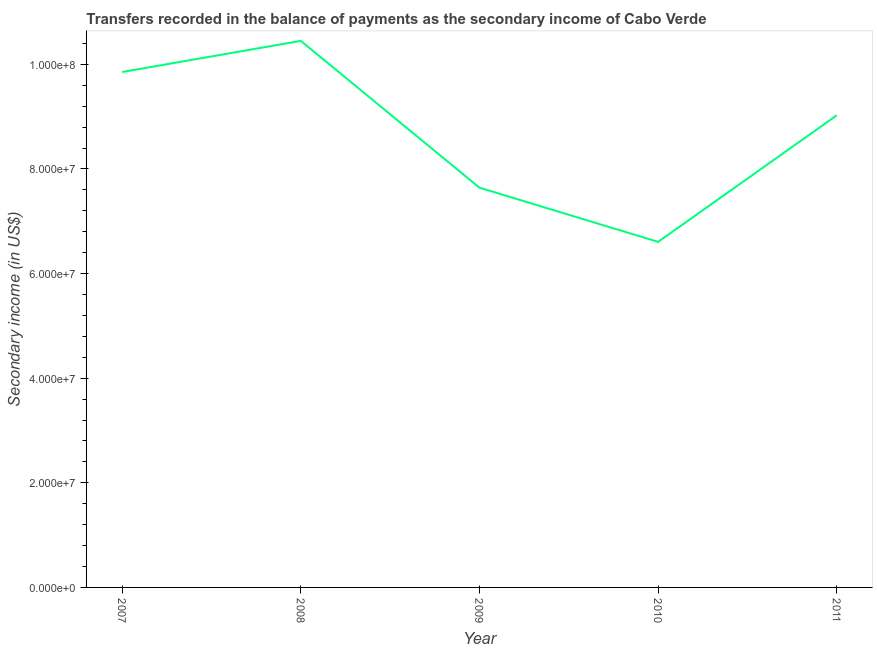What is the amount of secondary income in 2009?
Your answer should be very brief. 7.64e+07. Across all years, what is the maximum amount of secondary income?
Offer a very short reply. 1.04e+08. Across all years, what is the minimum amount of secondary income?
Your answer should be very brief. 6.61e+07. In which year was the amount of secondary income maximum?
Keep it short and to the point. 2008. What is the sum of the amount of secondary income?
Keep it short and to the point. 4.36e+08. What is the difference between the amount of secondary income in 2009 and 2010?
Offer a terse response. 1.04e+07. What is the average amount of secondary income per year?
Your answer should be very brief. 8.72e+07. What is the median amount of secondary income?
Provide a short and direct response. 9.03e+07. What is the ratio of the amount of secondary income in 2007 to that in 2008?
Ensure brevity in your answer.  0.94. Is the amount of secondary income in 2007 less than that in 2009?
Provide a short and direct response. No. Is the difference between the amount of secondary income in 2008 and 2010 greater than the difference between any two years?
Your answer should be very brief. Yes. What is the difference between the highest and the second highest amount of secondary income?
Make the answer very short. 5.95e+06. Is the sum of the amount of secondary income in 2007 and 2008 greater than the maximum amount of secondary income across all years?
Offer a terse response. Yes. What is the difference between the highest and the lowest amount of secondary income?
Your answer should be compact. 3.84e+07. Does the amount of secondary income monotonically increase over the years?
Your response must be concise. No. How many years are there in the graph?
Offer a terse response. 5. What is the title of the graph?
Offer a terse response. Transfers recorded in the balance of payments as the secondary income of Cabo Verde. What is the label or title of the X-axis?
Make the answer very short. Year. What is the label or title of the Y-axis?
Provide a succinct answer. Secondary income (in US$). What is the Secondary income (in US$) of 2007?
Offer a terse response. 9.85e+07. What is the Secondary income (in US$) of 2008?
Provide a succinct answer. 1.04e+08. What is the Secondary income (in US$) in 2009?
Provide a short and direct response. 7.64e+07. What is the Secondary income (in US$) of 2010?
Your answer should be compact. 6.61e+07. What is the Secondary income (in US$) in 2011?
Your answer should be very brief. 9.03e+07. What is the difference between the Secondary income (in US$) in 2007 and 2008?
Your response must be concise. -5.95e+06. What is the difference between the Secondary income (in US$) in 2007 and 2009?
Provide a short and direct response. 2.21e+07. What is the difference between the Secondary income (in US$) in 2007 and 2010?
Ensure brevity in your answer.  3.25e+07. What is the difference between the Secondary income (in US$) in 2007 and 2011?
Offer a very short reply. 8.28e+06. What is the difference between the Secondary income (in US$) in 2008 and 2009?
Your answer should be compact. 2.81e+07. What is the difference between the Secondary income (in US$) in 2008 and 2010?
Make the answer very short. 3.84e+07. What is the difference between the Secondary income (in US$) in 2008 and 2011?
Your answer should be compact. 1.42e+07. What is the difference between the Secondary income (in US$) in 2009 and 2010?
Give a very brief answer. 1.04e+07. What is the difference between the Secondary income (in US$) in 2009 and 2011?
Keep it short and to the point. -1.38e+07. What is the difference between the Secondary income (in US$) in 2010 and 2011?
Provide a short and direct response. -2.42e+07. What is the ratio of the Secondary income (in US$) in 2007 to that in 2008?
Offer a terse response. 0.94. What is the ratio of the Secondary income (in US$) in 2007 to that in 2009?
Your answer should be compact. 1.29. What is the ratio of the Secondary income (in US$) in 2007 to that in 2010?
Your answer should be compact. 1.49. What is the ratio of the Secondary income (in US$) in 2007 to that in 2011?
Keep it short and to the point. 1.09. What is the ratio of the Secondary income (in US$) in 2008 to that in 2009?
Ensure brevity in your answer.  1.37. What is the ratio of the Secondary income (in US$) in 2008 to that in 2010?
Make the answer very short. 1.58. What is the ratio of the Secondary income (in US$) in 2008 to that in 2011?
Your answer should be very brief. 1.16. What is the ratio of the Secondary income (in US$) in 2009 to that in 2010?
Ensure brevity in your answer.  1.16. What is the ratio of the Secondary income (in US$) in 2009 to that in 2011?
Give a very brief answer. 0.85. What is the ratio of the Secondary income (in US$) in 2010 to that in 2011?
Your answer should be very brief. 0.73. 